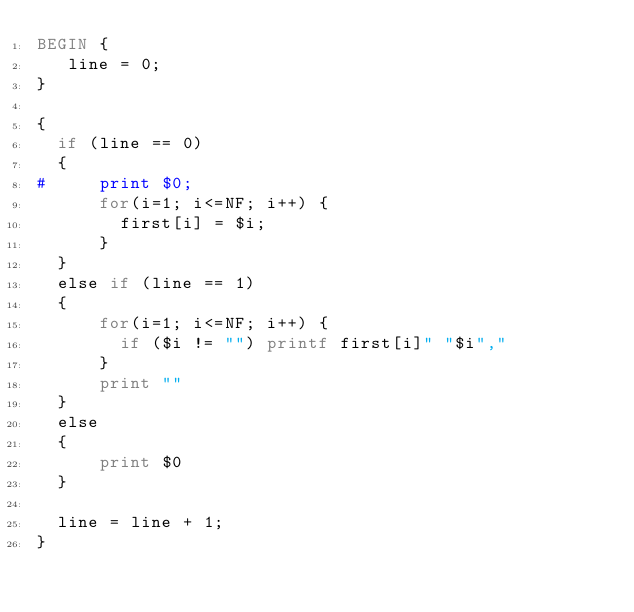<code> <loc_0><loc_0><loc_500><loc_500><_Awk_>BEGIN {
   line = 0;
}

{
  if (line == 0)
  {
#     print $0;
      for(i=1; i<=NF; i++) {
        first[i] = $i;
      }
  }
  else if (line == 1)
  {
      for(i=1; i<=NF; i++) {
        if ($i != "") printf first[i]" "$i","
      }
      print ""
  }
  else
  {
      print $0
  }

  line = line + 1;
}
</code> 